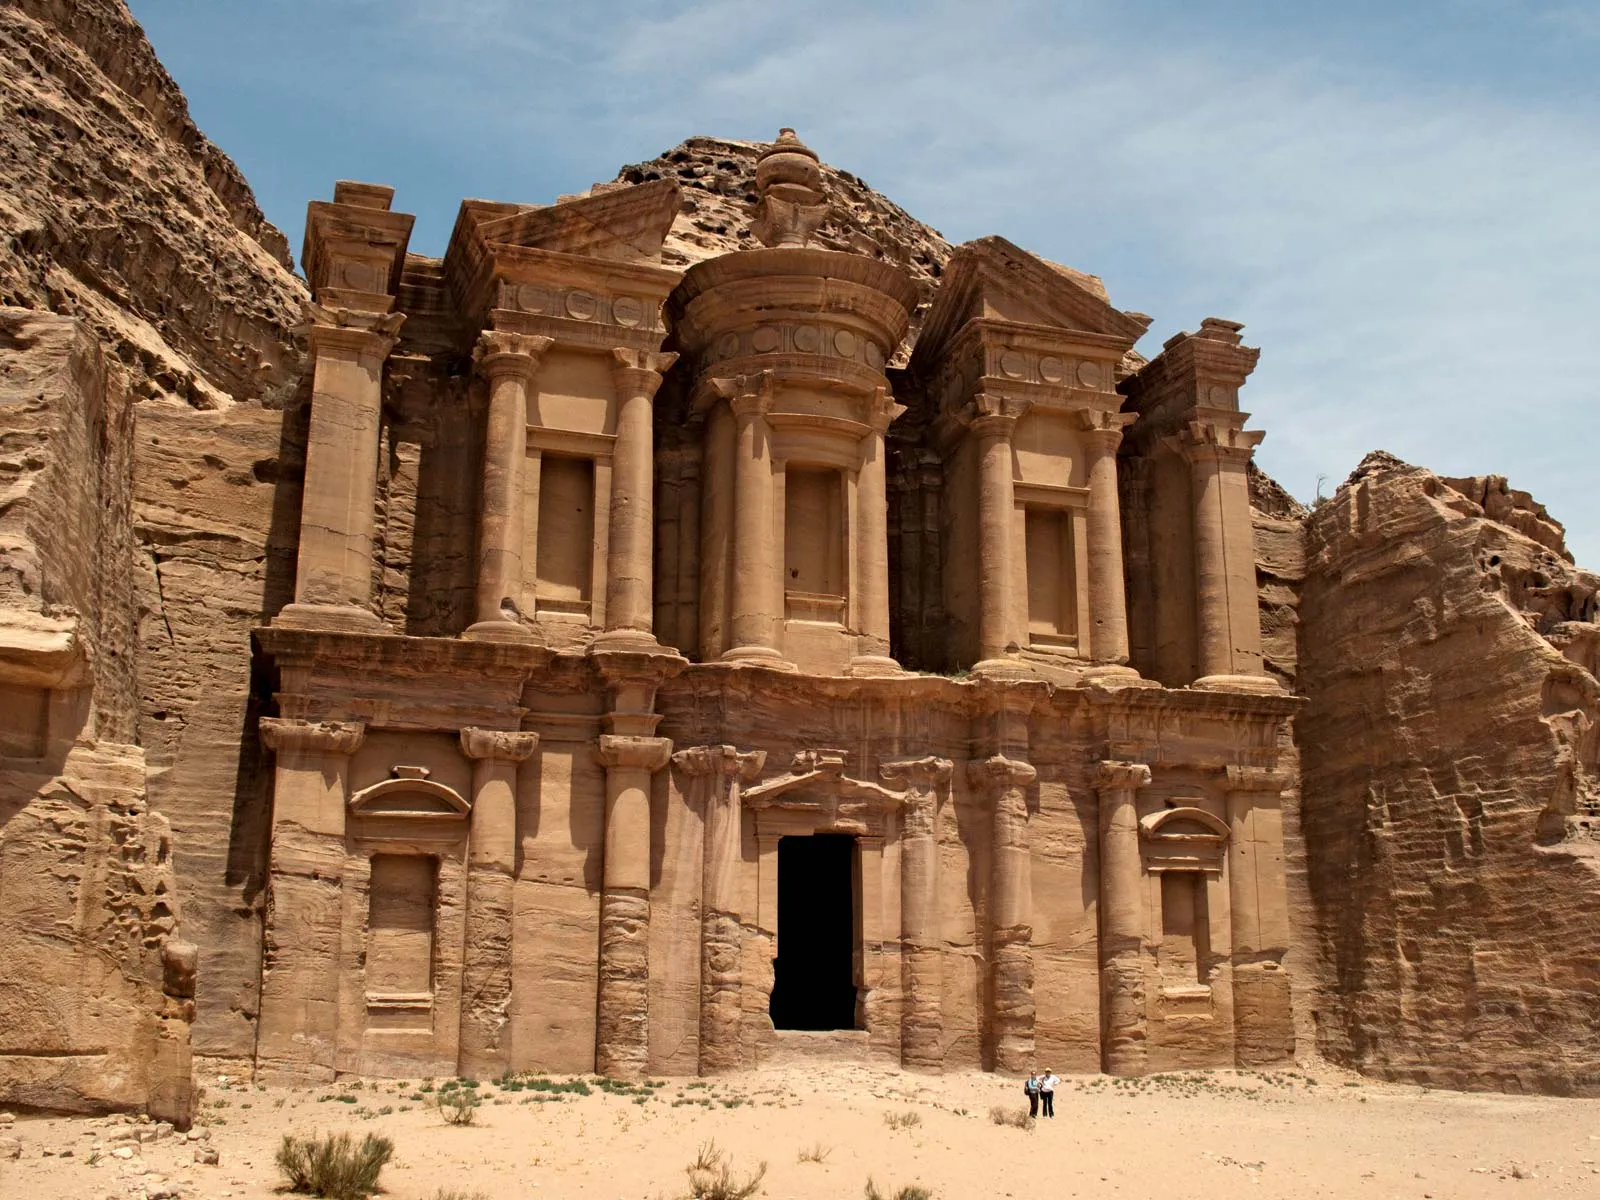Can you describe the main features of this image for me? This image showcases the iconic Monastery (Ad Deir) at Petra, Jordan. This colossal structure, carved directly into the pink sandstone cliffs, encapsulates the engineering marvel of the Nabateans from around the 1st century BC. The facade of the Monastery is adorned with columns and a large doorway, leading to a single cavernous room inside. The exterior features intricate bas-reliefs and classical pediments, reflecting the Nabatean blend of native traditions and Hellenistic architecture. The arid landscape and clear blue sky highlight the dramatic contrast with the rich, warm tones of the rock. Small human figures near the entrance underscore the massive scale of the Monastery, offering a perspective on how magnificent this ancient structure truly is. 